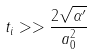<formula> <loc_0><loc_0><loc_500><loc_500>t _ { i } > > \frac { 2 \sqrt { \alpha ^ { \prime } } } { a _ { 0 } ^ { 2 } }</formula> 